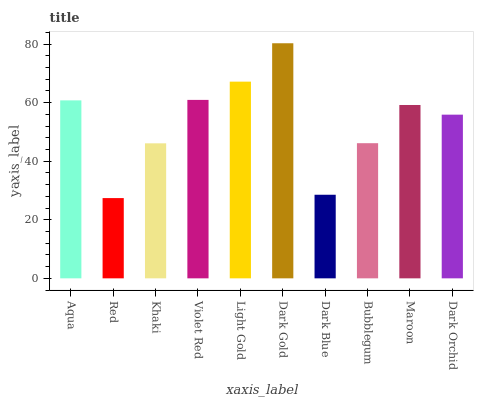Is Red the minimum?
Answer yes or no. Yes. Is Dark Gold the maximum?
Answer yes or no. Yes. Is Khaki the minimum?
Answer yes or no. No. Is Khaki the maximum?
Answer yes or no. No. Is Khaki greater than Red?
Answer yes or no. Yes. Is Red less than Khaki?
Answer yes or no. Yes. Is Red greater than Khaki?
Answer yes or no. No. Is Khaki less than Red?
Answer yes or no. No. Is Maroon the high median?
Answer yes or no. Yes. Is Dark Orchid the low median?
Answer yes or no. Yes. Is Bubblegum the high median?
Answer yes or no. No. Is Maroon the low median?
Answer yes or no. No. 